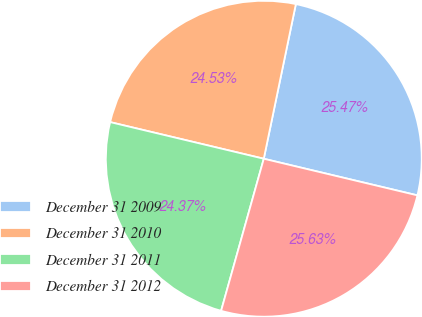Convert chart. <chart><loc_0><loc_0><loc_500><loc_500><pie_chart><fcel>December 31 2009<fcel>December 31 2010<fcel>December 31 2011<fcel>December 31 2012<nl><fcel>25.47%<fcel>24.53%<fcel>24.37%<fcel>25.63%<nl></chart> 